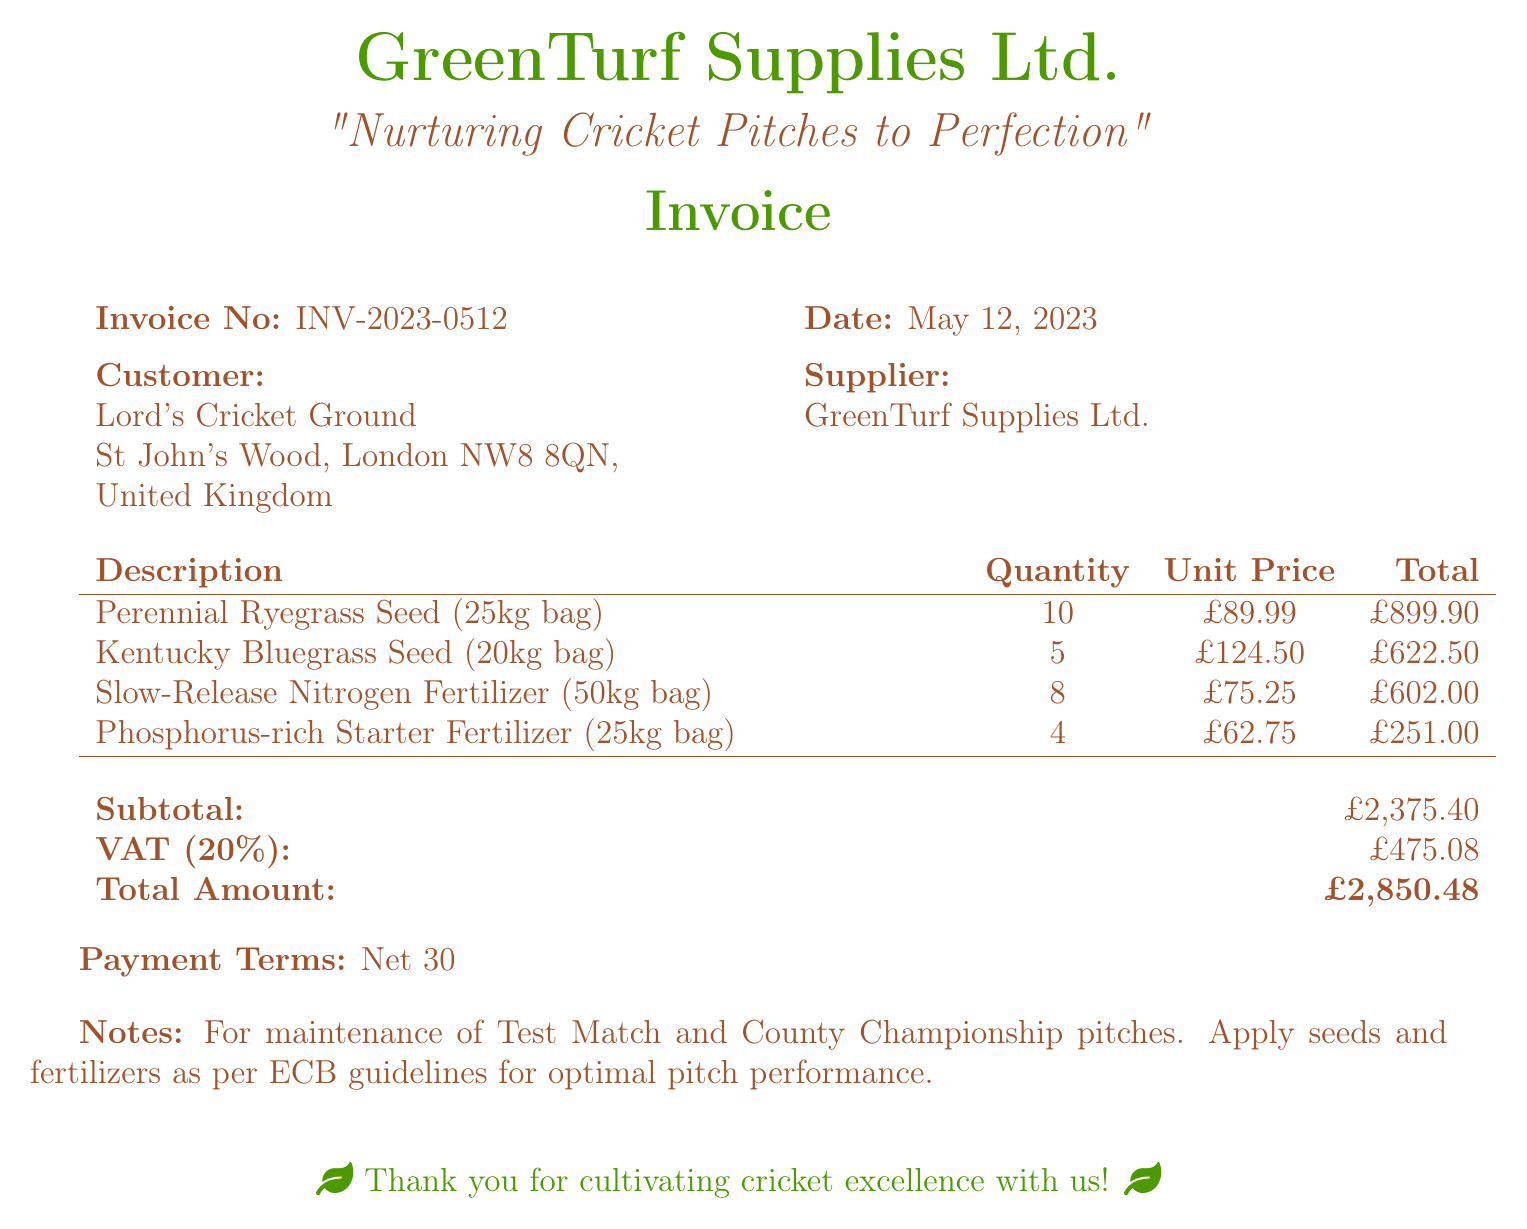What is the invoice number? The invoice number is provided in the document as a unique identifier for the transaction.
Answer: INV-2023-0512 What is the date of the invoice? The date indicates when this invoice was issued.
Answer: May 12, 2023 Who is the customer? The customer details are listed in the document and identify the recipient of the goods.
Answer: Lord's Cricket Ground How many bags of Kentucky Bluegrass Seed were purchased? This information is tracked in the table detailing the quantity of products bought.
Answer: 5 What is the subtotal amount? The subtotal reflects the total cost of goods before tax, as detailed in the invoice.
Answer: £2,375.40 What is the VAT percentage applied? The VAT percentage is stated in the document as a part of the calculations for tax.
Answer: 20% What is the total amount due? The total amount due is calculated and presented at the end of the invoice.
Answer: £2,850.48 What is the payment term provided? The payment term indicates the time frame for payment upon receiving the invoice.
Answer: Net 30 What type of fertilizers were included in the purchase? The types of fertilizers are listed within the product description section of the invoice.
Answer: Slow-Release Nitrogen Fertilizer, Phosphorus-rich Starter Fertilizer 